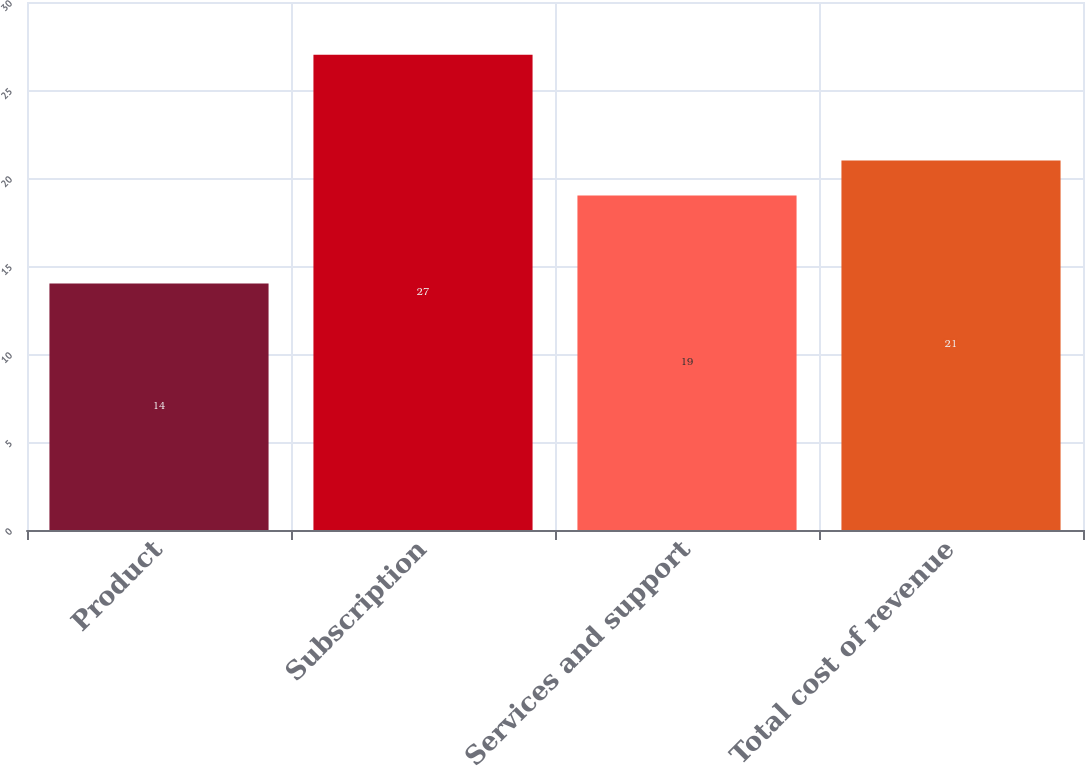<chart> <loc_0><loc_0><loc_500><loc_500><bar_chart><fcel>Product<fcel>Subscription<fcel>Services and support<fcel>Total cost of revenue<nl><fcel>14<fcel>27<fcel>19<fcel>21<nl></chart> 